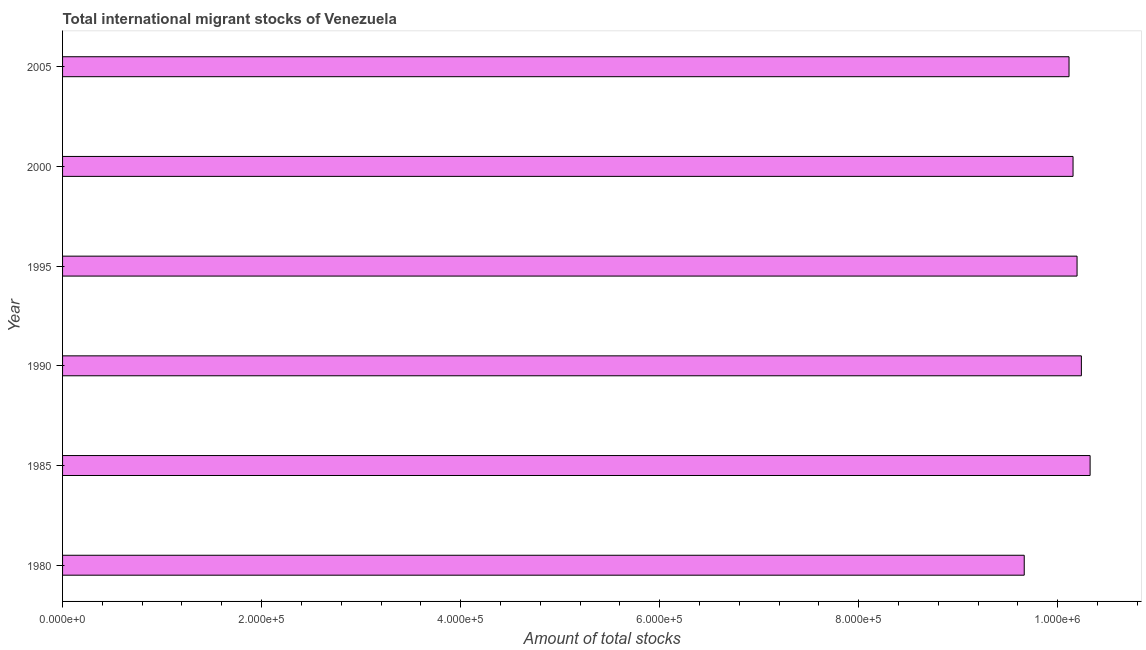What is the title of the graph?
Your answer should be very brief. Total international migrant stocks of Venezuela. What is the label or title of the X-axis?
Provide a succinct answer. Amount of total stocks. What is the total number of international migrant stock in 1985?
Offer a very short reply. 1.03e+06. Across all years, what is the maximum total number of international migrant stock?
Make the answer very short. 1.03e+06. Across all years, what is the minimum total number of international migrant stock?
Your answer should be compact. 9.66e+05. In which year was the total number of international migrant stock maximum?
Your answer should be compact. 1985. In which year was the total number of international migrant stock minimum?
Provide a succinct answer. 1980. What is the sum of the total number of international migrant stock?
Make the answer very short. 6.07e+06. What is the difference between the total number of international migrant stock in 1990 and 2000?
Give a very brief answer. 8378. What is the average total number of international migrant stock per year?
Provide a succinct answer. 1.01e+06. What is the median total number of international migrant stock?
Offer a very short reply. 1.02e+06. In how many years, is the total number of international migrant stock greater than 480000 ?
Make the answer very short. 6. Do a majority of the years between 1995 and 2005 (inclusive) have total number of international migrant stock greater than 640000 ?
Keep it short and to the point. Yes. What is the ratio of the total number of international migrant stock in 1985 to that in 1995?
Offer a terse response. 1.01. Is the difference between the total number of international migrant stock in 1990 and 1995 greater than the difference between any two years?
Provide a succinct answer. No. What is the difference between the highest and the second highest total number of international migrant stock?
Provide a succinct answer. 8778. Is the sum of the total number of international migrant stock in 1980 and 1985 greater than the maximum total number of international migrant stock across all years?
Provide a short and direct response. Yes. What is the difference between the highest and the lowest total number of international migrant stock?
Offer a terse response. 6.62e+04. In how many years, is the total number of international migrant stock greater than the average total number of international migrant stock taken over all years?
Keep it short and to the point. 4. What is the difference between two consecutive major ticks on the X-axis?
Your answer should be compact. 2.00e+05. What is the Amount of total stocks of 1980?
Offer a very short reply. 9.66e+05. What is the Amount of total stocks in 1985?
Ensure brevity in your answer.  1.03e+06. What is the Amount of total stocks of 1990?
Make the answer very short. 1.02e+06. What is the Amount of total stocks in 1995?
Make the answer very short. 1.02e+06. What is the Amount of total stocks of 2000?
Provide a short and direct response. 1.02e+06. What is the Amount of total stocks in 2005?
Give a very brief answer. 1.01e+06. What is the difference between the Amount of total stocks in 1980 and 1985?
Keep it short and to the point. -6.62e+04. What is the difference between the Amount of total stocks in 1980 and 1990?
Provide a succinct answer. -5.74e+04. What is the difference between the Amount of total stocks in 1980 and 1995?
Make the answer very short. -5.31e+04. What is the difference between the Amount of total stocks in 1980 and 2000?
Provide a succinct answer. -4.90e+04. What is the difference between the Amount of total stocks in 1980 and 2005?
Your response must be concise. -4.50e+04. What is the difference between the Amount of total stocks in 1985 and 1990?
Offer a terse response. 8778. What is the difference between the Amount of total stocks in 1985 and 1995?
Keep it short and to the point. 1.31e+04. What is the difference between the Amount of total stocks in 1985 and 2000?
Provide a succinct answer. 1.72e+04. What is the difference between the Amount of total stocks in 1985 and 2005?
Offer a very short reply. 2.12e+04. What is the difference between the Amount of total stocks in 1990 and 1995?
Keep it short and to the point. 4339. What is the difference between the Amount of total stocks in 1990 and 2000?
Offer a very short reply. 8378. What is the difference between the Amount of total stocks in 1990 and 2005?
Provide a short and direct response. 1.24e+04. What is the difference between the Amount of total stocks in 1995 and 2000?
Ensure brevity in your answer.  4039. What is the difference between the Amount of total stocks in 1995 and 2005?
Offer a very short reply. 8062. What is the difference between the Amount of total stocks in 2000 and 2005?
Offer a terse response. 4023. What is the ratio of the Amount of total stocks in 1980 to that in 1985?
Make the answer very short. 0.94. What is the ratio of the Amount of total stocks in 1980 to that in 1990?
Provide a succinct answer. 0.94. What is the ratio of the Amount of total stocks in 1980 to that in 1995?
Provide a succinct answer. 0.95. What is the ratio of the Amount of total stocks in 1980 to that in 2005?
Offer a terse response. 0.95. What is the ratio of the Amount of total stocks in 1985 to that in 1995?
Your answer should be very brief. 1.01. What is the ratio of the Amount of total stocks in 1985 to that in 2000?
Your response must be concise. 1.02. What is the ratio of the Amount of total stocks in 1990 to that in 1995?
Provide a short and direct response. 1. What is the ratio of the Amount of total stocks in 1990 to that in 2005?
Keep it short and to the point. 1.01. What is the ratio of the Amount of total stocks in 2000 to that in 2005?
Offer a very short reply. 1. 